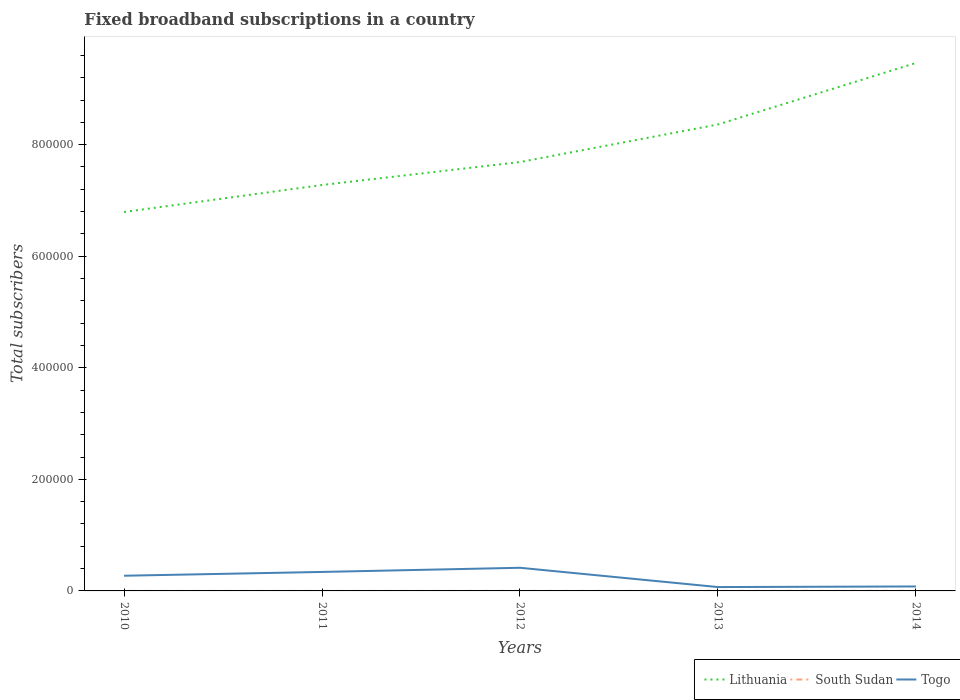How many different coloured lines are there?
Keep it short and to the point. 3. Is the number of lines equal to the number of legend labels?
Keep it short and to the point. Yes. Across all years, what is the maximum number of broadband subscriptions in South Sudan?
Give a very brief answer. 2. In which year was the number of broadband subscriptions in Togo maximum?
Offer a terse response. 2013. What is the total number of broadband subscriptions in Lithuania in the graph?
Keep it short and to the point. -6.73e+04. What is the difference between the highest and the second highest number of broadband subscriptions in Lithuania?
Make the answer very short. 2.67e+05. Is the number of broadband subscriptions in South Sudan strictly greater than the number of broadband subscriptions in Lithuania over the years?
Give a very brief answer. Yes. How many lines are there?
Offer a very short reply. 3. How many years are there in the graph?
Give a very brief answer. 5. What is the difference between two consecutive major ticks on the Y-axis?
Give a very brief answer. 2.00e+05. Are the values on the major ticks of Y-axis written in scientific E-notation?
Provide a succinct answer. No. How many legend labels are there?
Provide a succinct answer. 3. How are the legend labels stacked?
Give a very brief answer. Horizontal. What is the title of the graph?
Ensure brevity in your answer.  Fixed broadband subscriptions in a country. What is the label or title of the X-axis?
Offer a very short reply. Years. What is the label or title of the Y-axis?
Ensure brevity in your answer.  Total subscribers. What is the Total subscribers of Lithuania in 2010?
Offer a very short reply. 6.79e+05. What is the Total subscribers in Togo in 2010?
Provide a short and direct response. 2.72e+04. What is the Total subscribers in Lithuania in 2011?
Make the answer very short. 7.28e+05. What is the Total subscribers of Togo in 2011?
Make the answer very short. 3.40e+04. What is the Total subscribers of Lithuania in 2012?
Provide a short and direct response. 7.69e+05. What is the Total subscribers of Togo in 2012?
Offer a terse response. 4.15e+04. What is the Total subscribers in Lithuania in 2013?
Give a very brief answer. 8.36e+05. What is the Total subscribers in South Sudan in 2013?
Your answer should be very brief. 100. What is the Total subscribers of Togo in 2013?
Offer a terse response. 6915. What is the Total subscribers of Lithuania in 2014?
Your answer should be very brief. 9.46e+05. What is the Total subscribers in Togo in 2014?
Your response must be concise. 8000. Across all years, what is the maximum Total subscribers in Lithuania?
Your answer should be compact. 9.46e+05. Across all years, what is the maximum Total subscribers in South Sudan?
Provide a short and direct response. 100. Across all years, what is the maximum Total subscribers in Togo?
Offer a terse response. 4.15e+04. Across all years, what is the minimum Total subscribers in Lithuania?
Provide a short and direct response. 6.79e+05. Across all years, what is the minimum Total subscribers in South Sudan?
Give a very brief answer. 2. Across all years, what is the minimum Total subscribers of Togo?
Your answer should be compact. 6915. What is the total Total subscribers of Lithuania in the graph?
Offer a terse response. 3.96e+06. What is the total Total subscribers in South Sudan in the graph?
Keep it short and to the point. 223. What is the total Total subscribers in Togo in the graph?
Give a very brief answer. 1.18e+05. What is the difference between the Total subscribers of Lithuania in 2010 and that in 2011?
Ensure brevity in your answer.  -4.84e+04. What is the difference between the Total subscribers of South Sudan in 2010 and that in 2011?
Give a very brief answer. -2. What is the difference between the Total subscribers of Togo in 2010 and that in 2011?
Offer a terse response. -6814. What is the difference between the Total subscribers of Lithuania in 2010 and that in 2012?
Provide a short and direct response. -8.95e+04. What is the difference between the Total subscribers of South Sudan in 2010 and that in 2012?
Give a very brief answer. -15. What is the difference between the Total subscribers of Togo in 2010 and that in 2012?
Provide a succinct answer. -1.43e+04. What is the difference between the Total subscribers in Lithuania in 2010 and that in 2013?
Keep it short and to the point. -1.57e+05. What is the difference between the Total subscribers of South Sudan in 2010 and that in 2013?
Your answer should be compact. -98. What is the difference between the Total subscribers of Togo in 2010 and that in 2013?
Make the answer very short. 2.03e+04. What is the difference between the Total subscribers of Lithuania in 2010 and that in 2014?
Provide a succinct answer. -2.67e+05. What is the difference between the Total subscribers in South Sudan in 2010 and that in 2014?
Ensure brevity in your answer.  -98. What is the difference between the Total subscribers in Togo in 2010 and that in 2014?
Offer a terse response. 1.92e+04. What is the difference between the Total subscribers in Lithuania in 2011 and that in 2012?
Ensure brevity in your answer.  -4.12e+04. What is the difference between the Total subscribers of Togo in 2011 and that in 2012?
Provide a short and direct response. -7454. What is the difference between the Total subscribers of Lithuania in 2011 and that in 2013?
Your answer should be very brief. -1.09e+05. What is the difference between the Total subscribers in South Sudan in 2011 and that in 2013?
Provide a succinct answer. -96. What is the difference between the Total subscribers of Togo in 2011 and that in 2013?
Provide a succinct answer. 2.71e+04. What is the difference between the Total subscribers of Lithuania in 2011 and that in 2014?
Your answer should be very brief. -2.19e+05. What is the difference between the Total subscribers in South Sudan in 2011 and that in 2014?
Ensure brevity in your answer.  -96. What is the difference between the Total subscribers of Togo in 2011 and that in 2014?
Your response must be concise. 2.60e+04. What is the difference between the Total subscribers in Lithuania in 2012 and that in 2013?
Offer a terse response. -6.73e+04. What is the difference between the Total subscribers of South Sudan in 2012 and that in 2013?
Your answer should be compact. -83. What is the difference between the Total subscribers of Togo in 2012 and that in 2013?
Provide a succinct answer. 3.46e+04. What is the difference between the Total subscribers of Lithuania in 2012 and that in 2014?
Your answer should be compact. -1.78e+05. What is the difference between the Total subscribers of South Sudan in 2012 and that in 2014?
Your response must be concise. -83. What is the difference between the Total subscribers of Togo in 2012 and that in 2014?
Your answer should be very brief. 3.35e+04. What is the difference between the Total subscribers of Lithuania in 2013 and that in 2014?
Ensure brevity in your answer.  -1.10e+05. What is the difference between the Total subscribers of South Sudan in 2013 and that in 2014?
Give a very brief answer. 0. What is the difference between the Total subscribers in Togo in 2013 and that in 2014?
Keep it short and to the point. -1085. What is the difference between the Total subscribers of Lithuania in 2010 and the Total subscribers of South Sudan in 2011?
Provide a succinct answer. 6.79e+05. What is the difference between the Total subscribers in Lithuania in 2010 and the Total subscribers in Togo in 2011?
Give a very brief answer. 6.45e+05. What is the difference between the Total subscribers of South Sudan in 2010 and the Total subscribers of Togo in 2011?
Ensure brevity in your answer.  -3.40e+04. What is the difference between the Total subscribers of Lithuania in 2010 and the Total subscribers of South Sudan in 2012?
Keep it short and to the point. 6.79e+05. What is the difference between the Total subscribers in Lithuania in 2010 and the Total subscribers in Togo in 2012?
Make the answer very short. 6.38e+05. What is the difference between the Total subscribers in South Sudan in 2010 and the Total subscribers in Togo in 2012?
Offer a terse response. -4.15e+04. What is the difference between the Total subscribers in Lithuania in 2010 and the Total subscribers in South Sudan in 2013?
Offer a terse response. 6.79e+05. What is the difference between the Total subscribers in Lithuania in 2010 and the Total subscribers in Togo in 2013?
Provide a short and direct response. 6.72e+05. What is the difference between the Total subscribers in South Sudan in 2010 and the Total subscribers in Togo in 2013?
Give a very brief answer. -6913. What is the difference between the Total subscribers of Lithuania in 2010 and the Total subscribers of South Sudan in 2014?
Provide a succinct answer. 6.79e+05. What is the difference between the Total subscribers in Lithuania in 2010 and the Total subscribers in Togo in 2014?
Your answer should be very brief. 6.71e+05. What is the difference between the Total subscribers in South Sudan in 2010 and the Total subscribers in Togo in 2014?
Ensure brevity in your answer.  -7998. What is the difference between the Total subscribers in Lithuania in 2011 and the Total subscribers in South Sudan in 2012?
Provide a short and direct response. 7.28e+05. What is the difference between the Total subscribers in Lithuania in 2011 and the Total subscribers in Togo in 2012?
Ensure brevity in your answer.  6.86e+05. What is the difference between the Total subscribers in South Sudan in 2011 and the Total subscribers in Togo in 2012?
Give a very brief answer. -4.15e+04. What is the difference between the Total subscribers in Lithuania in 2011 and the Total subscribers in South Sudan in 2013?
Give a very brief answer. 7.28e+05. What is the difference between the Total subscribers in Lithuania in 2011 and the Total subscribers in Togo in 2013?
Keep it short and to the point. 7.21e+05. What is the difference between the Total subscribers of South Sudan in 2011 and the Total subscribers of Togo in 2013?
Keep it short and to the point. -6911. What is the difference between the Total subscribers of Lithuania in 2011 and the Total subscribers of South Sudan in 2014?
Provide a short and direct response. 7.28e+05. What is the difference between the Total subscribers of Lithuania in 2011 and the Total subscribers of Togo in 2014?
Make the answer very short. 7.20e+05. What is the difference between the Total subscribers of South Sudan in 2011 and the Total subscribers of Togo in 2014?
Provide a short and direct response. -7996. What is the difference between the Total subscribers in Lithuania in 2012 and the Total subscribers in South Sudan in 2013?
Ensure brevity in your answer.  7.69e+05. What is the difference between the Total subscribers in Lithuania in 2012 and the Total subscribers in Togo in 2013?
Your answer should be compact. 7.62e+05. What is the difference between the Total subscribers of South Sudan in 2012 and the Total subscribers of Togo in 2013?
Offer a terse response. -6898. What is the difference between the Total subscribers of Lithuania in 2012 and the Total subscribers of South Sudan in 2014?
Offer a very short reply. 7.69e+05. What is the difference between the Total subscribers of Lithuania in 2012 and the Total subscribers of Togo in 2014?
Your answer should be compact. 7.61e+05. What is the difference between the Total subscribers of South Sudan in 2012 and the Total subscribers of Togo in 2014?
Your answer should be compact. -7983. What is the difference between the Total subscribers of Lithuania in 2013 and the Total subscribers of South Sudan in 2014?
Provide a succinct answer. 8.36e+05. What is the difference between the Total subscribers of Lithuania in 2013 and the Total subscribers of Togo in 2014?
Your response must be concise. 8.28e+05. What is the difference between the Total subscribers of South Sudan in 2013 and the Total subscribers of Togo in 2014?
Offer a terse response. -7900. What is the average Total subscribers in Lithuania per year?
Offer a very short reply. 7.92e+05. What is the average Total subscribers in South Sudan per year?
Give a very brief answer. 44.6. What is the average Total subscribers of Togo per year?
Keep it short and to the point. 2.35e+04. In the year 2010, what is the difference between the Total subscribers of Lithuania and Total subscribers of South Sudan?
Provide a succinct answer. 6.79e+05. In the year 2010, what is the difference between the Total subscribers of Lithuania and Total subscribers of Togo?
Give a very brief answer. 6.52e+05. In the year 2010, what is the difference between the Total subscribers in South Sudan and Total subscribers in Togo?
Provide a short and direct response. -2.72e+04. In the year 2011, what is the difference between the Total subscribers of Lithuania and Total subscribers of South Sudan?
Provide a succinct answer. 7.28e+05. In the year 2011, what is the difference between the Total subscribers of Lithuania and Total subscribers of Togo?
Your answer should be very brief. 6.94e+05. In the year 2011, what is the difference between the Total subscribers of South Sudan and Total subscribers of Togo?
Offer a very short reply. -3.40e+04. In the year 2012, what is the difference between the Total subscribers in Lithuania and Total subscribers in South Sudan?
Give a very brief answer. 7.69e+05. In the year 2012, what is the difference between the Total subscribers of Lithuania and Total subscribers of Togo?
Your answer should be compact. 7.27e+05. In the year 2012, what is the difference between the Total subscribers of South Sudan and Total subscribers of Togo?
Keep it short and to the point. -4.15e+04. In the year 2013, what is the difference between the Total subscribers in Lithuania and Total subscribers in South Sudan?
Provide a short and direct response. 8.36e+05. In the year 2013, what is the difference between the Total subscribers in Lithuania and Total subscribers in Togo?
Your answer should be compact. 8.29e+05. In the year 2013, what is the difference between the Total subscribers of South Sudan and Total subscribers of Togo?
Make the answer very short. -6815. In the year 2014, what is the difference between the Total subscribers in Lithuania and Total subscribers in South Sudan?
Keep it short and to the point. 9.46e+05. In the year 2014, what is the difference between the Total subscribers in Lithuania and Total subscribers in Togo?
Make the answer very short. 9.38e+05. In the year 2014, what is the difference between the Total subscribers in South Sudan and Total subscribers in Togo?
Offer a terse response. -7900. What is the ratio of the Total subscribers in Lithuania in 2010 to that in 2011?
Provide a short and direct response. 0.93. What is the ratio of the Total subscribers of South Sudan in 2010 to that in 2011?
Offer a very short reply. 0.5. What is the ratio of the Total subscribers in Togo in 2010 to that in 2011?
Keep it short and to the point. 0.8. What is the ratio of the Total subscribers in Lithuania in 2010 to that in 2012?
Provide a short and direct response. 0.88. What is the ratio of the Total subscribers in South Sudan in 2010 to that in 2012?
Provide a short and direct response. 0.12. What is the ratio of the Total subscribers in Togo in 2010 to that in 2012?
Give a very brief answer. 0.66. What is the ratio of the Total subscribers of Lithuania in 2010 to that in 2013?
Provide a succinct answer. 0.81. What is the ratio of the Total subscribers in South Sudan in 2010 to that in 2013?
Give a very brief answer. 0.02. What is the ratio of the Total subscribers of Togo in 2010 to that in 2013?
Give a very brief answer. 3.94. What is the ratio of the Total subscribers of Lithuania in 2010 to that in 2014?
Keep it short and to the point. 0.72. What is the ratio of the Total subscribers of South Sudan in 2010 to that in 2014?
Your answer should be very brief. 0.02. What is the ratio of the Total subscribers in Togo in 2010 to that in 2014?
Your answer should be very brief. 3.4. What is the ratio of the Total subscribers of Lithuania in 2011 to that in 2012?
Your answer should be very brief. 0.95. What is the ratio of the Total subscribers of South Sudan in 2011 to that in 2012?
Offer a very short reply. 0.24. What is the ratio of the Total subscribers in Togo in 2011 to that in 2012?
Offer a very short reply. 0.82. What is the ratio of the Total subscribers in Lithuania in 2011 to that in 2013?
Your response must be concise. 0.87. What is the ratio of the Total subscribers of South Sudan in 2011 to that in 2013?
Provide a succinct answer. 0.04. What is the ratio of the Total subscribers of Togo in 2011 to that in 2013?
Ensure brevity in your answer.  4.92. What is the ratio of the Total subscribers in Lithuania in 2011 to that in 2014?
Your response must be concise. 0.77. What is the ratio of the Total subscribers in South Sudan in 2011 to that in 2014?
Offer a very short reply. 0.04. What is the ratio of the Total subscribers of Togo in 2011 to that in 2014?
Ensure brevity in your answer.  4.25. What is the ratio of the Total subscribers of Lithuania in 2012 to that in 2013?
Offer a very short reply. 0.92. What is the ratio of the Total subscribers in South Sudan in 2012 to that in 2013?
Your answer should be compact. 0.17. What is the ratio of the Total subscribers of Togo in 2012 to that in 2013?
Keep it short and to the point. 6. What is the ratio of the Total subscribers of Lithuania in 2012 to that in 2014?
Offer a very short reply. 0.81. What is the ratio of the Total subscribers of South Sudan in 2012 to that in 2014?
Keep it short and to the point. 0.17. What is the ratio of the Total subscribers in Togo in 2012 to that in 2014?
Make the answer very short. 5.19. What is the ratio of the Total subscribers of Lithuania in 2013 to that in 2014?
Keep it short and to the point. 0.88. What is the ratio of the Total subscribers in South Sudan in 2013 to that in 2014?
Your answer should be very brief. 1. What is the ratio of the Total subscribers of Togo in 2013 to that in 2014?
Give a very brief answer. 0.86. What is the difference between the highest and the second highest Total subscribers of Lithuania?
Provide a succinct answer. 1.10e+05. What is the difference between the highest and the second highest Total subscribers of Togo?
Make the answer very short. 7454. What is the difference between the highest and the lowest Total subscribers of Lithuania?
Provide a succinct answer. 2.67e+05. What is the difference between the highest and the lowest Total subscribers in Togo?
Your answer should be compact. 3.46e+04. 